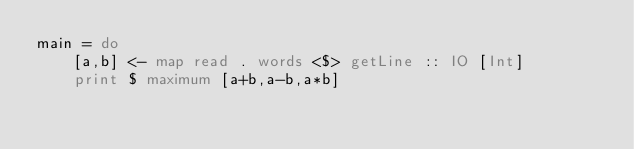Convert code to text. <code><loc_0><loc_0><loc_500><loc_500><_Haskell_>main = do
    [a,b] <- map read . words <$> getLine :: IO [Int]
    print $ maximum [a+b,a-b,a*b]
</code> 